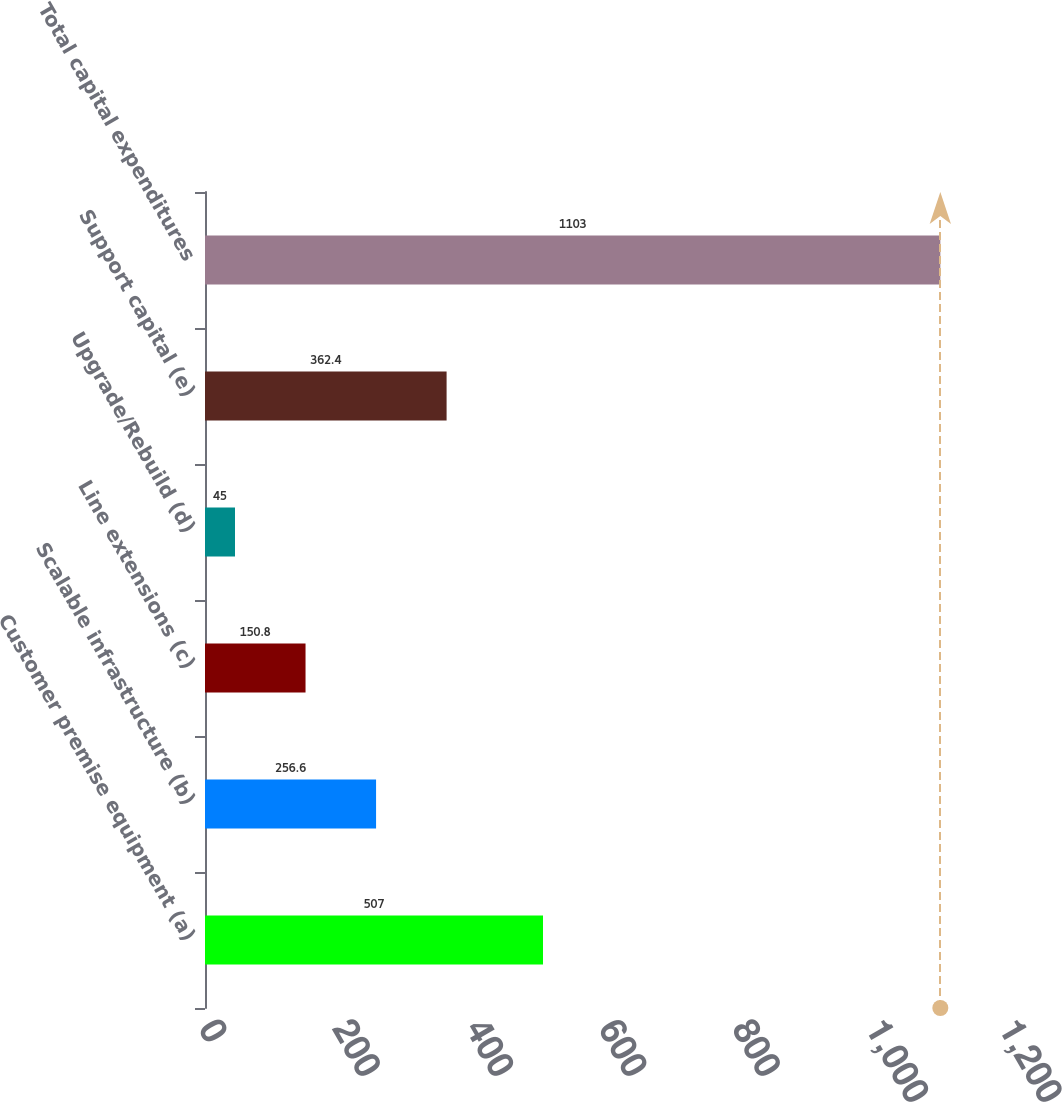Convert chart to OTSL. <chart><loc_0><loc_0><loc_500><loc_500><bar_chart><fcel>Customer premise equipment (a)<fcel>Scalable infrastructure (b)<fcel>Line extensions (c)<fcel>Upgrade/Rebuild (d)<fcel>Support capital (e)<fcel>Total capital expenditures<nl><fcel>507<fcel>256.6<fcel>150.8<fcel>45<fcel>362.4<fcel>1103<nl></chart> 